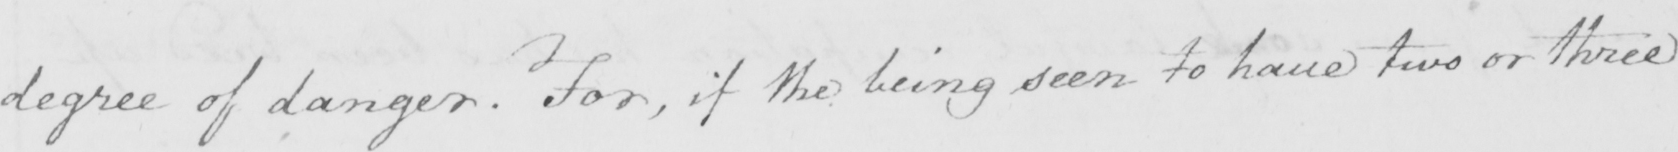Transcribe the text shown in this historical manuscript line. degree of danger . For , if the being seen to have two or three 